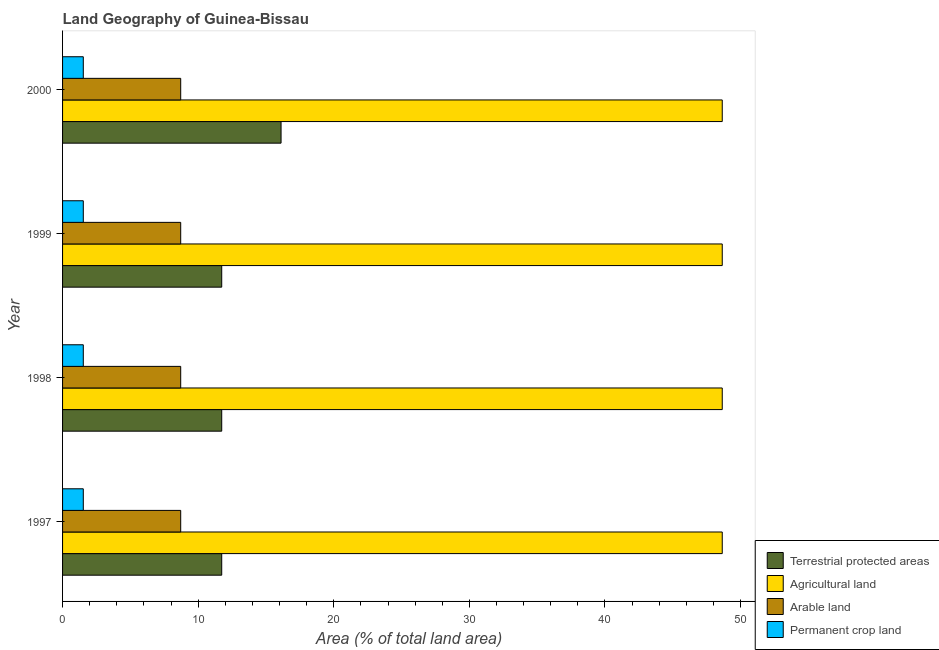How many different coloured bars are there?
Keep it short and to the point. 4. Are the number of bars per tick equal to the number of legend labels?
Ensure brevity in your answer.  Yes. Are the number of bars on each tick of the Y-axis equal?
Provide a short and direct response. Yes. How many bars are there on the 3rd tick from the top?
Provide a succinct answer. 4. What is the label of the 3rd group of bars from the top?
Your answer should be compact. 1998. What is the percentage of area under agricultural land in 1999?
Your answer should be compact. 48.65. Across all years, what is the maximum percentage of area under agricultural land?
Provide a short and direct response. 48.65. Across all years, what is the minimum percentage of area under permanent crop land?
Give a very brief answer. 1.53. In which year was the percentage of area under arable land minimum?
Your answer should be very brief. 1997. What is the total percentage of land under terrestrial protection in the graph?
Your response must be concise. 51.33. What is the difference between the percentage of land under terrestrial protection in 1998 and that in 1999?
Keep it short and to the point. 0. What is the difference between the percentage of area under arable land in 1999 and the percentage of area under agricultural land in 1998?
Your answer should be very brief. -39.94. What is the average percentage of area under permanent crop land per year?
Make the answer very short. 1.53. In the year 2000, what is the difference between the percentage of area under agricultural land and percentage of area under permanent crop land?
Provide a succinct answer. 47.12. Is the difference between the percentage of land under terrestrial protection in 1997 and 2000 greater than the difference between the percentage of area under agricultural land in 1997 and 2000?
Provide a short and direct response. No. In how many years, is the percentage of area under permanent crop land greater than the average percentage of area under permanent crop land taken over all years?
Offer a very short reply. 0. Is it the case that in every year, the sum of the percentage of area under permanent crop land and percentage of area under arable land is greater than the sum of percentage of land under terrestrial protection and percentage of area under agricultural land?
Offer a terse response. No. What does the 4th bar from the top in 1999 represents?
Your response must be concise. Terrestrial protected areas. What does the 4th bar from the bottom in 1999 represents?
Your answer should be very brief. Permanent crop land. How many years are there in the graph?
Your answer should be very brief. 4. Are the values on the major ticks of X-axis written in scientific E-notation?
Give a very brief answer. No. Does the graph contain grids?
Keep it short and to the point. No. Where does the legend appear in the graph?
Provide a short and direct response. Bottom right. How are the legend labels stacked?
Make the answer very short. Vertical. What is the title of the graph?
Provide a succinct answer. Land Geography of Guinea-Bissau. Does "Natural Gas" appear as one of the legend labels in the graph?
Your response must be concise. No. What is the label or title of the X-axis?
Provide a short and direct response. Area (% of total land area). What is the label or title of the Y-axis?
Offer a very short reply. Year. What is the Area (% of total land area) of Terrestrial protected areas in 1997?
Offer a very short reply. 11.74. What is the Area (% of total land area) in Agricultural land in 1997?
Keep it short and to the point. 48.65. What is the Area (% of total land area) of Arable land in 1997?
Your response must be concise. 8.71. What is the Area (% of total land area) in Permanent crop land in 1997?
Offer a very short reply. 1.53. What is the Area (% of total land area) of Terrestrial protected areas in 1998?
Your answer should be very brief. 11.74. What is the Area (% of total land area) in Agricultural land in 1998?
Offer a very short reply. 48.65. What is the Area (% of total land area) in Arable land in 1998?
Your response must be concise. 8.71. What is the Area (% of total land area) of Permanent crop land in 1998?
Keep it short and to the point. 1.53. What is the Area (% of total land area) of Terrestrial protected areas in 1999?
Your answer should be compact. 11.74. What is the Area (% of total land area) in Agricultural land in 1999?
Your answer should be compact. 48.65. What is the Area (% of total land area) of Arable land in 1999?
Give a very brief answer. 8.71. What is the Area (% of total land area) of Permanent crop land in 1999?
Your answer should be compact. 1.53. What is the Area (% of total land area) of Terrestrial protected areas in 2000?
Your answer should be compact. 16.11. What is the Area (% of total land area) in Agricultural land in 2000?
Your answer should be very brief. 48.65. What is the Area (% of total land area) of Arable land in 2000?
Provide a short and direct response. 8.71. What is the Area (% of total land area) in Permanent crop land in 2000?
Offer a very short reply. 1.53. Across all years, what is the maximum Area (% of total land area) of Terrestrial protected areas?
Offer a terse response. 16.11. Across all years, what is the maximum Area (% of total land area) in Agricultural land?
Offer a terse response. 48.65. Across all years, what is the maximum Area (% of total land area) in Arable land?
Ensure brevity in your answer.  8.71. Across all years, what is the maximum Area (% of total land area) in Permanent crop land?
Provide a succinct answer. 1.53. Across all years, what is the minimum Area (% of total land area) in Terrestrial protected areas?
Provide a succinct answer. 11.74. Across all years, what is the minimum Area (% of total land area) of Agricultural land?
Your response must be concise. 48.65. Across all years, what is the minimum Area (% of total land area) of Arable land?
Offer a very short reply. 8.71. Across all years, what is the minimum Area (% of total land area) in Permanent crop land?
Provide a succinct answer. 1.53. What is the total Area (% of total land area) of Terrestrial protected areas in the graph?
Keep it short and to the point. 51.33. What is the total Area (% of total land area) in Agricultural land in the graph?
Ensure brevity in your answer.  194.59. What is the total Area (% of total land area) of Arable land in the graph?
Provide a short and direct response. 34.85. What is the total Area (% of total land area) of Permanent crop land in the graph?
Your answer should be compact. 6.12. What is the difference between the Area (% of total land area) in Terrestrial protected areas in 1997 and that in 1998?
Your answer should be very brief. 0. What is the difference between the Area (% of total land area) in Arable land in 1997 and that in 1998?
Offer a terse response. 0. What is the difference between the Area (% of total land area) in Agricultural land in 1997 and that in 1999?
Your answer should be very brief. 0. What is the difference between the Area (% of total land area) in Arable land in 1997 and that in 1999?
Ensure brevity in your answer.  0. What is the difference between the Area (% of total land area) of Terrestrial protected areas in 1997 and that in 2000?
Offer a very short reply. -4.38. What is the difference between the Area (% of total land area) in Arable land in 1998 and that in 1999?
Ensure brevity in your answer.  0. What is the difference between the Area (% of total land area) in Permanent crop land in 1998 and that in 1999?
Provide a succinct answer. 0. What is the difference between the Area (% of total land area) in Terrestrial protected areas in 1998 and that in 2000?
Offer a terse response. -4.38. What is the difference between the Area (% of total land area) in Arable land in 1998 and that in 2000?
Offer a terse response. 0. What is the difference between the Area (% of total land area) of Terrestrial protected areas in 1999 and that in 2000?
Your response must be concise. -4.38. What is the difference between the Area (% of total land area) in Agricultural land in 1999 and that in 2000?
Make the answer very short. 0. What is the difference between the Area (% of total land area) in Arable land in 1999 and that in 2000?
Ensure brevity in your answer.  0. What is the difference between the Area (% of total land area) of Permanent crop land in 1999 and that in 2000?
Provide a succinct answer. 0. What is the difference between the Area (% of total land area) of Terrestrial protected areas in 1997 and the Area (% of total land area) of Agricultural land in 1998?
Offer a terse response. -36.91. What is the difference between the Area (% of total land area) in Terrestrial protected areas in 1997 and the Area (% of total land area) in Arable land in 1998?
Give a very brief answer. 3.02. What is the difference between the Area (% of total land area) in Terrestrial protected areas in 1997 and the Area (% of total land area) in Permanent crop land in 1998?
Give a very brief answer. 10.21. What is the difference between the Area (% of total land area) of Agricultural land in 1997 and the Area (% of total land area) of Arable land in 1998?
Provide a succinct answer. 39.94. What is the difference between the Area (% of total land area) in Agricultural land in 1997 and the Area (% of total land area) in Permanent crop land in 1998?
Your answer should be very brief. 47.12. What is the difference between the Area (% of total land area) in Arable land in 1997 and the Area (% of total land area) in Permanent crop land in 1998?
Ensure brevity in your answer.  7.18. What is the difference between the Area (% of total land area) in Terrestrial protected areas in 1997 and the Area (% of total land area) in Agricultural land in 1999?
Offer a very short reply. -36.91. What is the difference between the Area (% of total land area) of Terrestrial protected areas in 1997 and the Area (% of total land area) of Arable land in 1999?
Give a very brief answer. 3.02. What is the difference between the Area (% of total land area) in Terrestrial protected areas in 1997 and the Area (% of total land area) in Permanent crop land in 1999?
Give a very brief answer. 10.21. What is the difference between the Area (% of total land area) in Agricultural land in 1997 and the Area (% of total land area) in Arable land in 1999?
Make the answer very short. 39.94. What is the difference between the Area (% of total land area) in Agricultural land in 1997 and the Area (% of total land area) in Permanent crop land in 1999?
Provide a succinct answer. 47.12. What is the difference between the Area (% of total land area) in Arable land in 1997 and the Area (% of total land area) in Permanent crop land in 1999?
Ensure brevity in your answer.  7.18. What is the difference between the Area (% of total land area) of Terrestrial protected areas in 1997 and the Area (% of total land area) of Agricultural land in 2000?
Your answer should be very brief. -36.91. What is the difference between the Area (% of total land area) of Terrestrial protected areas in 1997 and the Area (% of total land area) of Arable land in 2000?
Give a very brief answer. 3.02. What is the difference between the Area (% of total land area) in Terrestrial protected areas in 1997 and the Area (% of total land area) in Permanent crop land in 2000?
Your answer should be very brief. 10.21. What is the difference between the Area (% of total land area) of Agricultural land in 1997 and the Area (% of total land area) of Arable land in 2000?
Ensure brevity in your answer.  39.94. What is the difference between the Area (% of total land area) in Agricultural land in 1997 and the Area (% of total land area) in Permanent crop land in 2000?
Your answer should be compact. 47.12. What is the difference between the Area (% of total land area) of Arable land in 1997 and the Area (% of total land area) of Permanent crop land in 2000?
Give a very brief answer. 7.18. What is the difference between the Area (% of total land area) in Terrestrial protected areas in 1998 and the Area (% of total land area) in Agricultural land in 1999?
Offer a very short reply. -36.91. What is the difference between the Area (% of total land area) in Terrestrial protected areas in 1998 and the Area (% of total land area) in Arable land in 1999?
Keep it short and to the point. 3.02. What is the difference between the Area (% of total land area) in Terrestrial protected areas in 1998 and the Area (% of total land area) in Permanent crop land in 1999?
Your answer should be very brief. 10.21. What is the difference between the Area (% of total land area) in Agricultural land in 1998 and the Area (% of total land area) in Arable land in 1999?
Provide a short and direct response. 39.94. What is the difference between the Area (% of total land area) in Agricultural land in 1998 and the Area (% of total land area) in Permanent crop land in 1999?
Make the answer very short. 47.12. What is the difference between the Area (% of total land area) in Arable land in 1998 and the Area (% of total land area) in Permanent crop land in 1999?
Offer a terse response. 7.18. What is the difference between the Area (% of total land area) of Terrestrial protected areas in 1998 and the Area (% of total land area) of Agricultural land in 2000?
Ensure brevity in your answer.  -36.91. What is the difference between the Area (% of total land area) of Terrestrial protected areas in 1998 and the Area (% of total land area) of Arable land in 2000?
Your answer should be very brief. 3.02. What is the difference between the Area (% of total land area) in Terrestrial protected areas in 1998 and the Area (% of total land area) in Permanent crop land in 2000?
Your answer should be very brief. 10.21. What is the difference between the Area (% of total land area) of Agricultural land in 1998 and the Area (% of total land area) of Arable land in 2000?
Your response must be concise. 39.94. What is the difference between the Area (% of total land area) in Agricultural land in 1998 and the Area (% of total land area) in Permanent crop land in 2000?
Offer a terse response. 47.12. What is the difference between the Area (% of total land area) in Arable land in 1998 and the Area (% of total land area) in Permanent crop land in 2000?
Offer a terse response. 7.18. What is the difference between the Area (% of total land area) of Terrestrial protected areas in 1999 and the Area (% of total land area) of Agricultural land in 2000?
Ensure brevity in your answer.  -36.91. What is the difference between the Area (% of total land area) in Terrestrial protected areas in 1999 and the Area (% of total land area) in Arable land in 2000?
Give a very brief answer. 3.02. What is the difference between the Area (% of total land area) of Terrestrial protected areas in 1999 and the Area (% of total land area) of Permanent crop land in 2000?
Offer a terse response. 10.21. What is the difference between the Area (% of total land area) in Agricultural land in 1999 and the Area (% of total land area) in Arable land in 2000?
Make the answer very short. 39.94. What is the difference between the Area (% of total land area) of Agricultural land in 1999 and the Area (% of total land area) of Permanent crop land in 2000?
Provide a succinct answer. 47.12. What is the difference between the Area (% of total land area) of Arable land in 1999 and the Area (% of total land area) of Permanent crop land in 2000?
Keep it short and to the point. 7.18. What is the average Area (% of total land area) in Terrestrial protected areas per year?
Provide a succinct answer. 12.83. What is the average Area (% of total land area) in Agricultural land per year?
Offer a terse response. 48.65. What is the average Area (% of total land area) of Arable land per year?
Make the answer very short. 8.71. What is the average Area (% of total land area) in Permanent crop land per year?
Make the answer very short. 1.53. In the year 1997, what is the difference between the Area (% of total land area) of Terrestrial protected areas and Area (% of total land area) of Agricultural land?
Your response must be concise. -36.91. In the year 1997, what is the difference between the Area (% of total land area) in Terrestrial protected areas and Area (% of total land area) in Arable land?
Provide a short and direct response. 3.02. In the year 1997, what is the difference between the Area (% of total land area) of Terrestrial protected areas and Area (% of total land area) of Permanent crop land?
Your response must be concise. 10.21. In the year 1997, what is the difference between the Area (% of total land area) in Agricultural land and Area (% of total land area) in Arable land?
Offer a very short reply. 39.94. In the year 1997, what is the difference between the Area (% of total land area) of Agricultural land and Area (% of total land area) of Permanent crop land?
Offer a very short reply. 47.12. In the year 1997, what is the difference between the Area (% of total land area) in Arable land and Area (% of total land area) in Permanent crop land?
Your answer should be compact. 7.18. In the year 1998, what is the difference between the Area (% of total land area) in Terrestrial protected areas and Area (% of total land area) in Agricultural land?
Offer a terse response. -36.91. In the year 1998, what is the difference between the Area (% of total land area) of Terrestrial protected areas and Area (% of total land area) of Arable land?
Your answer should be very brief. 3.02. In the year 1998, what is the difference between the Area (% of total land area) in Terrestrial protected areas and Area (% of total land area) in Permanent crop land?
Your answer should be very brief. 10.21. In the year 1998, what is the difference between the Area (% of total land area) in Agricultural land and Area (% of total land area) in Arable land?
Provide a succinct answer. 39.94. In the year 1998, what is the difference between the Area (% of total land area) in Agricultural land and Area (% of total land area) in Permanent crop land?
Make the answer very short. 47.12. In the year 1998, what is the difference between the Area (% of total land area) in Arable land and Area (% of total land area) in Permanent crop land?
Provide a short and direct response. 7.18. In the year 1999, what is the difference between the Area (% of total land area) in Terrestrial protected areas and Area (% of total land area) in Agricultural land?
Your answer should be compact. -36.91. In the year 1999, what is the difference between the Area (% of total land area) of Terrestrial protected areas and Area (% of total land area) of Arable land?
Offer a terse response. 3.02. In the year 1999, what is the difference between the Area (% of total land area) of Terrestrial protected areas and Area (% of total land area) of Permanent crop land?
Your answer should be very brief. 10.21. In the year 1999, what is the difference between the Area (% of total land area) in Agricultural land and Area (% of total land area) in Arable land?
Give a very brief answer. 39.94. In the year 1999, what is the difference between the Area (% of total land area) of Agricultural land and Area (% of total land area) of Permanent crop land?
Provide a succinct answer. 47.12. In the year 1999, what is the difference between the Area (% of total land area) of Arable land and Area (% of total land area) of Permanent crop land?
Offer a terse response. 7.18. In the year 2000, what is the difference between the Area (% of total land area) of Terrestrial protected areas and Area (% of total land area) of Agricultural land?
Ensure brevity in your answer.  -32.54. In the year 2000, what is the difference between the Area (% of total land area) in Terrestrial protected areas and Area (% of total land area) in Arable land?
Provide a short and direct response. 7.4. In the year 2000, what is the difference between the Area (% of total land area) in Terrestrial protected areas and Area (% of total land area) in Permanent crop land?
Your response must be concise. 14.58. In the year 2000, what is the difference between the Area (% of total land area) in Agricultural land and Area (% of total land area) in Arable land?
Provide a short and direct response. 39.94. In the year 2000, what is the difference between the Area (% of total land area) of Agricultural land and Area (% of total land area) of Permanent crop land?
Make the answer very short. 47.12. In the year 2000, what is the difference between the Area (% of total land area) in Arable land and Area (% of total land area) in Permanent crop land?
Ensure brevity in your answer.  7.18. What is the ratio of the Area (% of total land area) of Terrestrial protected areas in 1997 to that in 1998?
Ensure brevity in your answer.  1. What is the ratio of the Area (% of total land area) of Arable land in 1997 to that in 1998?
Your answer should be very brief. 1. What is the ratio of the Area (% of total land area) of Agricultural land in 1997 to that in 1999?
Make the answer very short. 1. What is the ratio of the Area (% of total land area) in Arable land in 1997 to that in 1999?
Make the answer very short. 1. What is the ratio of the Area (% of total land area) in Terrestrial protected areas in 1997 to that in 2000?
Your answer should be very brief. 0.73. What is the ratio of the Area (% of total land area) of Permanent crop land in 1997 to that in 2000?
Your answer should be compact. 1. What is the ratio of the Area (% of total land area) in Agricultural land in 1998 to that in 1999?
Your answer should be compact. 1. What is the ratio of the Area (% of total land area) of Arable land in 1998 to that in 1999?
Offer a very short reply. 1. What is the ratio of the Area (% of total land area) of Terrestrial protected areas in 1998 to that in 2000?
Keep it short and to the point. 0.73. What is the ratio of the Area (% of total land area) of Agricultural land in 1998 to that in 2000?
Keep it short and to the point. 1. What is the ratio of the Area (% of total land area) in Arable land in 1998 to that in 2000?
Provide a succinct answer. 1. What is the ratio of the Area (% of total land area) of Permanent crop land in 1998 to that in 2000?
Ensure brevity in your answer.  1. What is the ratio of the Area (% of total land area) of Terrestrial protected areas in 1999 to that in 2000?
Make the answer very short. 0.73. What is the ratio of the Area (% of total land area) of Agricultural land in 1999 to that in 2000?
Your response must be concise. 1. What is the ratio of the Area (% of total land area) of Permanent crop land in 1999 to that in 2000?
Give a very brief answer. 1. What is the difference between the highest and the second highest Area (% of total land area) of Terrestrial protected areas?
Your answer should be compact. 4.38. What is the difference between the highest and the second highest Area (% of total land area) in Agricultural land?
Your answer should be compact. 0. What is the difference between the highest and the second highest Area (% of total land area) of Arable land?
Provide a succinct answer. 0. What is the difference between the highest and the second highest Area (% of total land area) in Permanent crop land?
Your answer should be compact. 0. What is the difference between the highest and the lowest Area (% of total land area) of Terrestrial protected areas?
Offer a terse response. 4.38. What is the difference between the highest and the lowest Area (% of total land area) in Agricultural land?
Provide a short and direct response. 0. What is the difference between the highest and the lowest Area (% of total land area) in Arable land?
Ensure brevity in your answer.  0. 